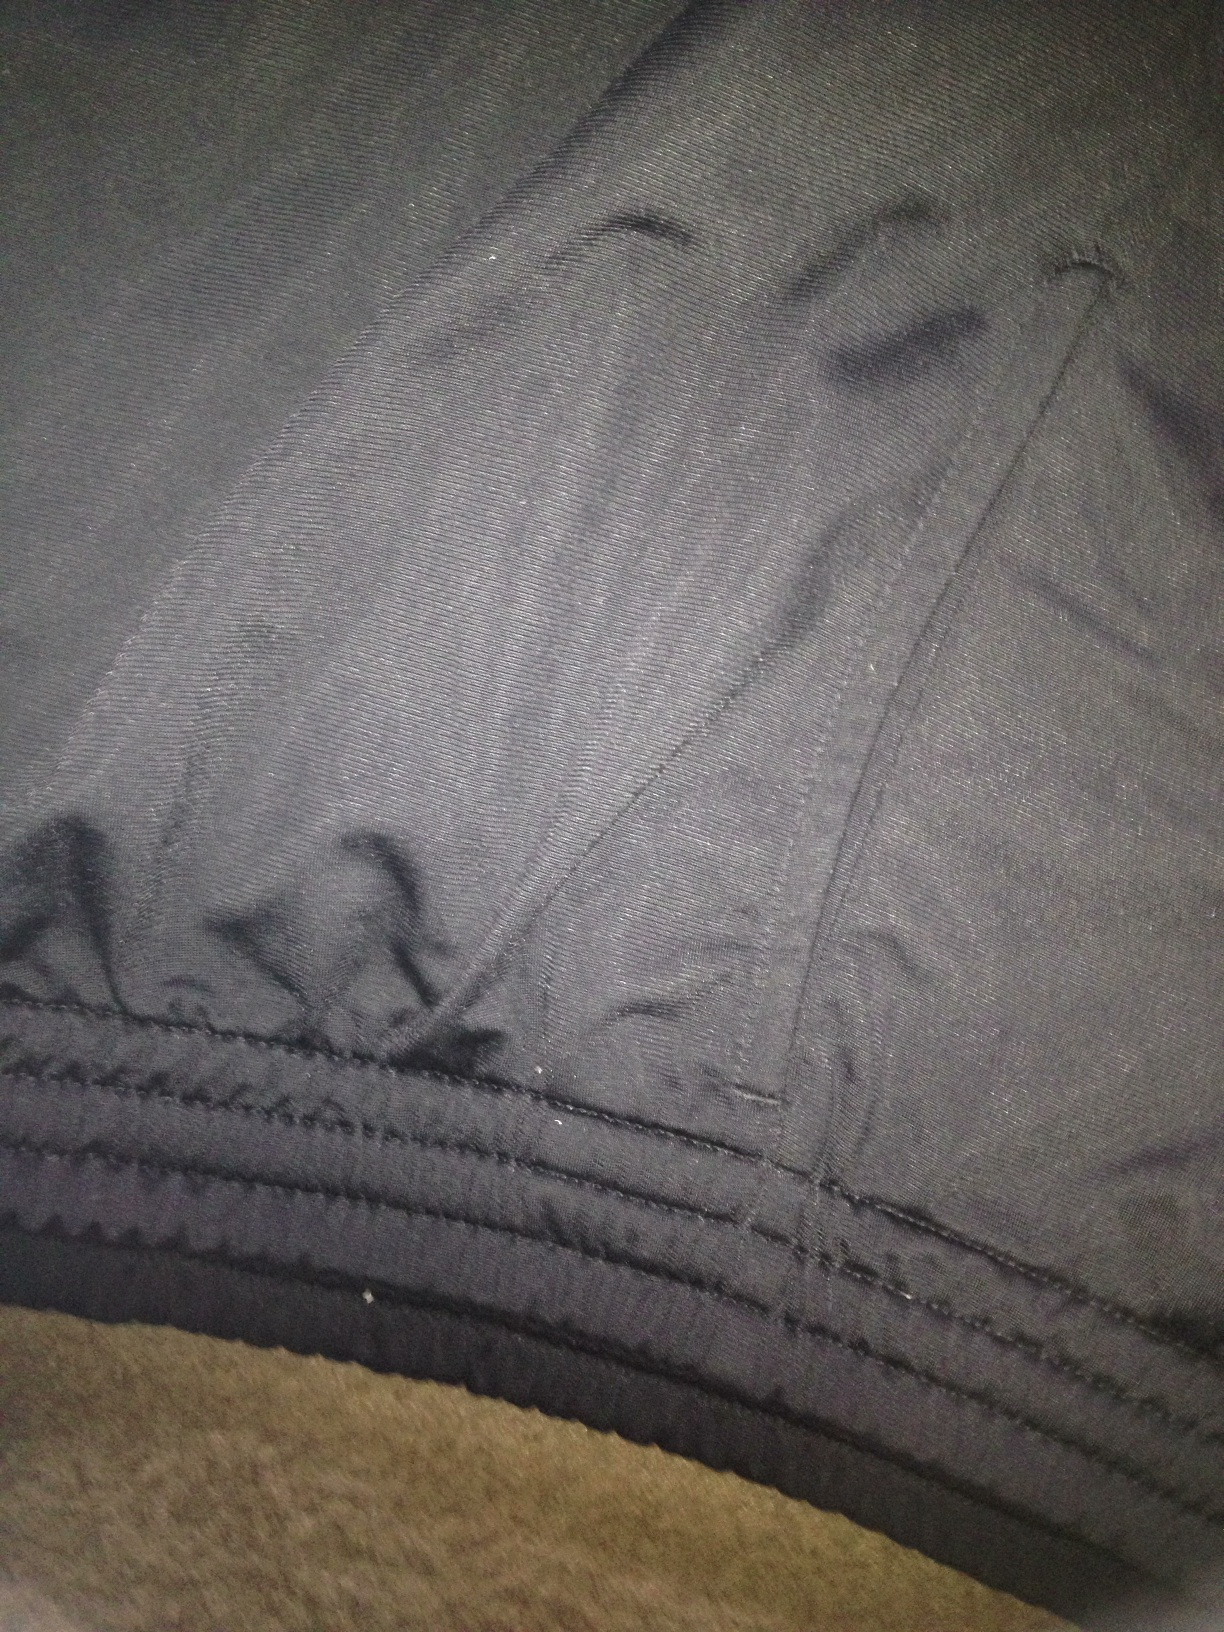What do these pants suggest about the wearer's personality? The wearer of these pants might value comfort and practicality, evident from the sturdy fabric and detailed stitching. They prefer a subtle, muted look, indicating a possibly reserved and pragmatic personality. The choice of grey suggests an appreciation for neutral tones and versatility in their wardrobe. How would these pants fit into a streetwear outfit? These grey pants would be a great addition to a streetwear outfit. Pair them with a graphic t-shirt, a denim jacket, and a pair of high-top sneakers for a casual and stylish look. Accessorize with a beanie and a backpack to complete the streetwear vibe. 